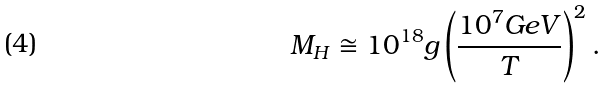Convert formula to latex. <formula><loc_0><loc_0><loc_500><loc_500>M _ { H } \cong 1 0 ^ { 1 8 } g \left ( \frac { 1 0 ^ { 7 } G e V } { T } \right ) ^ { 2 } .</formula> 